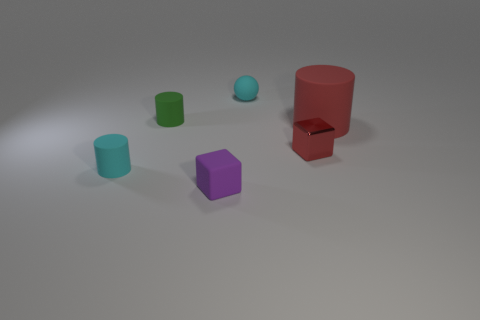Subtract all tiny matte cylinders. How many cylinders are left? 1 Subtract 2 blocks. How many blocks are left? 0 Add 3 small gray shiny cylinders. How many objects exist? 9 Add 4 red matte cubes. How many red matte cubes exist? 4 Subtract all red cylinders. How many cylinders are left? 2 Subtract 0 brown spheres. How many objects are left? 6 Subtract all cubes. How many objects are left? 4 Subtract all gray balls. Subtract all brown cubes. How many balls are left? 1 Subtract all cyan balls. How many purple cubes are left? 1 Subtract all green matte cylinders. Subtract all big things. How many objects are left? 4 